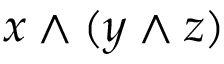<formula> <loc_0><loc_0><loc_500><loc_500>x \wedge ( y \wedge z )</formula> 